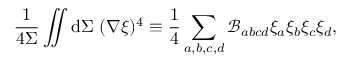Convert formula to latex. <formula><loc_0><loc_0><loc_500><loc_500>\frac { 1 } { 4 \Sigma } \iint d \Sigma ( \nabla \xi ) ^ { 4 } \equiv \frac { 1 } { 4 } \sum _ { a , b , c , d } \mathcal { B } _ { a b c d } \xi _ { a } \xi _ { b } \xi _ { c } \xi _ { d } ,</formula> 